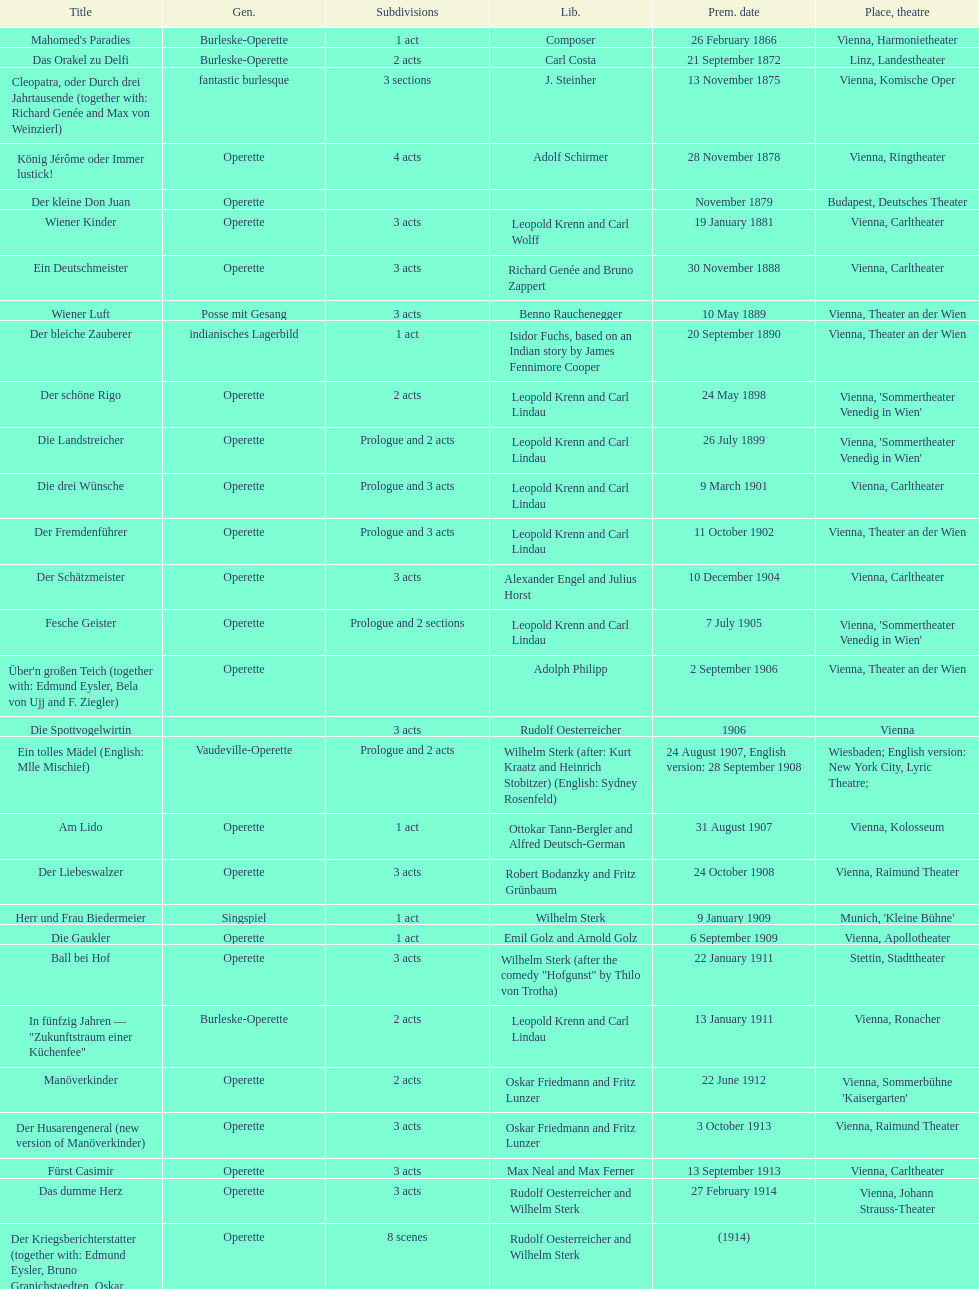Parse the full table. {'header': ['Title', 'Gen.', 'Sub\xaddivisions', 'Lib.', 'Prem. date', 'Place, theatre'], 'rows': [["Mahomed's Paradies", 'Burleske-Operette', '1 act', 'Composer', '26 February 1866', 'Vienna, Harmonietheater'], ['Das Orakel zu Delfi', 'Burleske-Operette', '2 acts', 'Carl Costa', '21 September 1872', 'Linz, Landestheater'], ['Cleopatra, oder Durch drei Jahrtausende (together with: Richard Genée and Max von Weinzierl)', 'fantastic burlesque', '3 sections', 'J. Steinher', '13 November 1875', 'Vienna, Komische Oper'], ['König Jérôme oder Immer lustick!', 'Operette', '4 acts', 'Adolf Schirmer', '28 November 1878', 'Vienna, Ringtheater'], ['Der kleine Don Juan', 'Operette', '', '', 'November 1879', 'Budapest, Deutsches Theater'], ['Wiener Kinder', 'Operette', '3 acts', 'Leopold Krenn and Carl Wolff', '19 January 1881', 'Vienna, Carltheater'], ['Ein Deutschmeister', 'Operette', '3 acts', 'Richard Genée and Bruno Zappert', '30 November 1888', 'Vienna, Carltheater'], ['Wiener Luft', 'Posse mit Gesang', '3 acts', 'Benno Rauchenegger', '10 May 1889', 'Vienna, Theater an der Wien'], ['Der bleiche Zauberer', 'indianisches Lagerbild', '1 act', 'Isidor Fuchs, based on an Indian story by James Fennimore Cooper', '20 September 1890', 'Vienna, Theater an der Wien'], ['Der schöne Rigo', 'Operette', '2 acts', 'Leopold Krenn and Carl Lindau', '24 May 1898', "Vienna, 'Sommertheater Venedig in Wien'"], ['Die Landstreicher', 'Operette', 'Prologue and 2 acts', 'Leopold Krenn and Carl Lindau', '26 July 1899', "Vienna, 'Sommertheater Venedig in Wien'"], ['Die drei Wünsche', 'Operette', 'Prologue and 3 acts', 'Leopold Krenn and Carl Lindau', '9 March 1901', 'Vienna, Carltheater'], ['Der Fremdenführer', 'Operette', 'Prologue and 3 acts', 'Leopold Krenn and Carl Lindau', '11 October 1902', 'Vienna, Theater an der Wien'], ['Der Schätzmeister', 'Operette', '3 acts', 'Alexander Engel and Julius Horst', '10 December 1904', 'Vienna, Carltheater'], ['Fesche Geister', 'Operette', 'Prologue and 2 sections', 'Leopold Krenn and Carl Lindau', '7 July 1905', "Vienna, 'Sommertheater Venedig in Wien'"], ["Über'n großen Teich (together with: Edmund Eysler, Bela von Ujj and F. Ziegler)", 'Operette', '', 'Adolph Philipp', '2 September 1906', 'Vienna, Theater an der Wien'], ['Die Spottvogelwirtin', '', '3 acts', 'Rudolf Oesterreicher', '1906', 'Vienna'], ['Ein tolles Mädel (English: Mlle Mischief)', 'Vaudeville-Operette', 'Prologue and 2 acts', 'Wilhelm Sterk (after: Kurt Kraatz and Heinrich Stobitzer) (English: Sydney Rosenfeld)', '24 August 1907, English version: 28 September 1908', 'Wiesbaden; English version: New York City, Lyric Theatre;'], ['Am Lido', 'Operette', '1 act', 'Ottokar Tann-Bergler and Alfred Deutsch-German', '31 August 1907', 'Vienna, Kolosseum'], ['Der Liebeswalzer', 'Operette', '3 acts', 'Robert Bodanzky and Fritz Grünbaum', '24 October 1908', 'Vienna, Raimund Theater'], ['Herr und Frau Biedermeier', 'Singspiel', '1 act', 'Wilhelm Sterk', '9 January 1909', "Munich, 'Kleine Bühne'"], ['Die Gaukler', 'Operette', '1 act', 'Emil Golz and Arnold Golz', '6 September 1909', 'Vienna, Apollotheater'], ['Ball bei Hof', 'Operette', '3 acts', 'Wilhelm Sterk (after the comedy "Hofgunst" by Thilo von Trotha)', '22 January 1911', 'Stettin, Stadttheater'], ['In fünfzig Jahren — "Zukunftstraum einer Küchenfee"', 'Burleske-Operette', '2 acts', 'Leopold Krenn and Carl Lindau', '13 January 1911', 'Vienna, Ronacher'], ['Manöverkinder', 'Operette', '2 acts', 'Oskar Friedmann and Fritz Lunzer', '22 June 1912', "Vienna, Sommerbühne 'Kaisergarten'"], ['Der Husarengeneral (new version of Manöverkinder)', 'Operette', '3 acts', 'Oskar Friedmann and Fritz Lunzer', '3 October 1913', 'Vienna, Raimund Theater'], ['Fürst Casimir', 'Operette', '3 acts', 'Max Neal and Max Ferner', '13 September 1913', 'Vienna, Carltheater'], ['Das dumme Herz', 'Operette', '3 acts', 'Rudolf Oesterreicher and Wilhelm Sterk', '27 February 1914', 'Vienna, Johann Strauss-Theater'], ['Der Kriegsberichterstatter (together with: Edmund Eysler, Bruno Granichstaedten, Oskar Nedbal, Charles Weinberger)', 'Operette', '8 scenes', 'Rudolf Oesterreicher and Wilhelm Sterk', '(1914)', ''], ['Im siebenten Himmel', 'Operette', '3 acts', 'Max Neal and Max Ferner', '26 February 1916', 'Munich, Theater am Gärtnerplatz'], ['Deutschmeisterkapelle', 'Operette', '', 'Hubert Marischka and Rudolf Oesterreicher', '30 May 1958', 'Vienna, Raimund Theater'], ['Die verliebte Eskadron', 'Operette', '3 acts', 'Wilhelm Sterk (after B. Buchbinder)', '11 July 1930', 'Vienna, Johann-Strauß-Theater']]} What are the number of titles that premiered in the month of september? 4. 